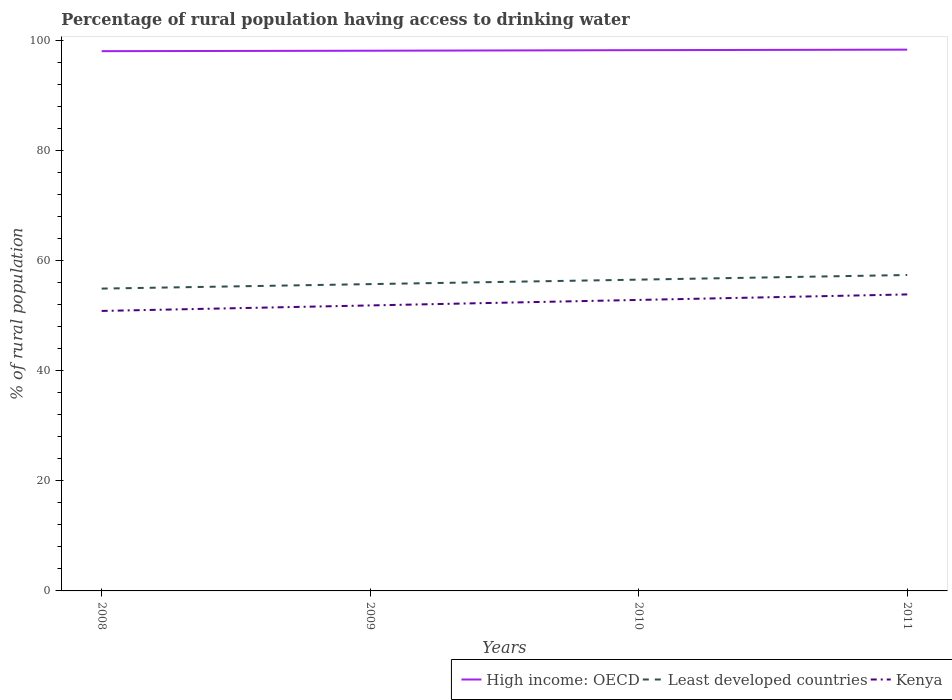How many different coloured lines are there?
Keep it short and to the point. 3. Does the line corresponding to Least developed countries intersect with the line corresponding to Kenya?
Provide a short and direct response. No. Is the number of lines equal to the number of legend labels?
Offer a very short reply. Yes. Across all years, what is the maximum percentage of rural population having access to drinking water in Least developed countries?
Your answer should be compact. 54.96. What is the total percentage of rural population having access to drinking water in Least developed countries in the graph?
Give a very brief answer. -1.66. What is the difference between the highest and the second highest percentage of rural population having access to drinking water in High income: OECD?
Your answer should be compact. 0.28. What is the difference between the highest and the lowest percentage of rural population having access to drinking water in High income: OECD?
Make the answer very short. 2. How many lines are there?
Offer a very short reply. 3. What is the difference between two consecutive major ticks on the Y-axis?
Offer a very short reply. 20. Are the values on the major ticks of Y-axis written in scientific E-notation?
Provide a succinct answer. No. Does the graph contain grids?
Offer a very short reply. No. Where does the legend appear in the graph?
Provide a short and direct response. Bottom right. What is the title of the graph?
Ensure brevity in your answer.  Percentage of rural population having access to drinking water. Does "Iraq" appear as one of the legend labels in the graph?
Give a very brief answer. No. What is the label or title of the Y-axis?
Provide a succinct answer. % of rural population. What is the % of rural population of High income: OECD in 2008?
Your answer should be very brief. 98.12. What is the % of rural population of Least developed countries in 2008?
Offer a terse response. 54.96. What is the % of rural population of Kenya in 2008?
Offer a very short reply. 50.9. What is the % of rural population in High income: OECD in 2009?
Your answer should be very brief. 98.2. What is the % of rural population of Least developed countries in 2009?
Provide a short and direct response. 55.77. What is the % of rural population of Kenya in 2009?
Provide a short and direct response. 51.9. What is the % of rural population of High income: OECD in 2010?
Provide a succinct answer. 98.31. What is the % of rural population in Least developed countries in 2010?
Provide a succinct answer. 56.59. What is the % of rural population in Kenya in 2010?
Your response must be concise. 52.9. What is the % of rural population in High income: OECD in 2011?
Give a very brief answer. 98.4. What is the % of rural population in Least developed countries in 2011?
Keep it short and to the point. 57.43. What is the % of rural population of Kenya in 2011?
Provide a short and direct response. 53.9. Across all years, what is the maximum % of rural population of High income: OECD?
Your response must be concise. 98.4. Across all years, what is the maximum % of rural population in Least developed countries?
Give a very brief answer. 57.43. Across all years, what is the maximum % of rural population in Kenya?
Ensure brevity in your answer.  53.9. Across all years, what is the minimum % of rural population in High income: OECD?
Your answer should be very brief. 98.12. Across all years, what is the minimum % of rural population in Least developed countries?
Your answer should be compact. 54.96. Across all years, what is the minimum % of rural population in Kenya?
Your response must be concise. 50.9. What is the total % of rural population in High income: OECD in the graph?
Give a very brief answer. 393.03. What is the total % of rural population in Least developed countries in the graph?
Make the answer very short. 224.75. What is the total % of rural population in Kenya in the graph?
Give a very brief answer. 209.6. What is the difference between the % of rural population in High income: OECD in 2008 and that in 2009?
Offer a terse response. -0.08. What is the difference between the % of rural population of Least developed countries in 2008 and that in 2009?
Offer a very short reply. -0.81. What is the difference between the % of rural population in High income: OECD in 2008 and that in 2010?
Your answer should be compact. -0.18. What is the difference between the % of rural population in Least developed countries in 2008 and that in 2010?
Your answer should be compact. -1.63. What is the difference between the % of rural population of Kenya in 2008 and that in 2010?
Your answer should be compact. -2. What is the difference between the % of rural population of High income: OECD in 2008 and that in 2011?
Offer a terse response. -0.28. What is the difference between the % of rural population in Least developed countries in 2008 and that in 2011?
Keep it short and to the point. -2.47. What is the difference between the % of rural population of Kenya in 2008 and that in 2011?
Ensure brevity in your answer.  -3. What is the difference between the % of rural population of High income: OECD in 2009 and that in 2010?
Keep it short and to the point. -0.1. What is the difference between the % of rural population in Least developed countries in 2009 and that in 2010?
Give a very brief answer. -0.81. What is the difference between the % of rural population in Kenya in 2009 and that in 2010?
Make the answer very short. -1. What is the difference between the % of rural population of High income: OECD in 2009 and that in 2011?
Give a very brief answer. -0.2. What is the difference between the % of rural population of Least developed countries in 2009 and that in 2011?
Provide a short and direct response. -1.66. What is the difference between the % of rural population in Kenya in 2009 and that in 2011?
Keep it short and to the point. -2. What is the difference between the % of rural population in High income: OECD in 2010 and that in 2011?
Your response must be concise. -0.09. What is the difference between the % of rural population in Least developed countries in 2010 and that in 2011?
Give a very brief answer. -0.84. What is the difference between the % of rural population in High income: OECD in 2008 and the % of rural population in Least developed countries in 2009?
Give a very brief answer. 42.35. What is the difference between the % of rural population of High income: OECD in 2008 and the % of rural population of Kenya in 2009?
Give a very brief answer. 46.22. What is the difference between the % of rural population of Least developed countries in 2008 and the % of rural population of Kenya in 2009?
Your answer should be compact. 3.06. What is the difference between the % of rural population in High income: OECD in 2008 and the % of rural population in Least developed countries in 2010?
Keep it short and to the point. 41.53. What is the difference between the % of rural population of High income: OECD in 2008 and the % of rural population of Kenya in 2010?
Make the answer very short. 45.22. What is the difference between the % of rural population of Least developed countries in 2008 and the % of rural population of Kenya in 2010?
Your answer should be compact. 2.06. What is the difference between the % of rural population in High income: OECD in 2008 and the % of rural population in Least developed countries in 2011?
Your answer should be very brief. 40.69. What is the difference between the % of rural population in High income: OECD in 2008 and the % of rural population in Kenya in 2011?
Your answer should be very brief. 44.22. What is the difference between the % of rural population of Least developed countries in 2008 and the % of rural population of Kenya in 2011?
Give a very brief answer. 1.06. What is the difference between the % of rural population in High income: OECD in 2009 and the % of rural population in Least developed countries in 2010?
Your answer should be compact. 41.62. What is the difference between the % of rural population of High income: OECD in 2009 and the % of rural population of Kenya in 2010?
Your response must be concise. 45.3. What is the difference between the % of rural population in Least developed countries in 2009 and the % of rural population in Kenya in 2010?
Ensure brevity in your answer.  2.87. What is the difference between the % of rural population in High income: OECD in 2009 and the % of rural population in Least developed countries in 2011?
Keep it short and to the point. 40.77. What is the difference between the % of rural population in High income: OECD in 2009 and the % of rural population in Kenya in 2011?
Keep it short and to the point. 44.3. What is the difference between the % of rural population of Least developed countries in 2009 and the % of rural population of Kenya in 2011?
Ensure brevity in your answer.  1.87. What is the difference between the % of rural population in High income: OECD in 2010 and the % of rural population in Least developed countries in 2011?
Offer a very short reply. 40.88. What is the difference between the % of rural population of High income: OECD in 2010 and the % of rural population of Kenya in 2011?
Keep it short and to the point. 44.41. What is the difference between the % of rural population in Least developed countries in 2010 and the % of rural population in Kenya in 2011?
Your answer should be very brief. 2.69. What is the average % of rural population in High income: OECD per year?
Keep it short and to the point. 98.26. What is the average % of rural population of Least developed countries per year?
Offer a terse response. 56.19. What is the average % of rural population of Kenya per year?
Give a very brief answer. 52.4. In the year 2008, what is the difference between the % of rural population of High income: OECD and % of rural population of Least developed countries?
Give a very brief answer. 43.16. In the year 2008, what is the difference between the % of rural population of High income: OECD and % of rural population of Kenya?
Give a very brief answer. 47.22. In the year 2008, what is the difference between the % of rural population of Least developed countries and % of rural population of Kenya?
Your response must be concise. 4.06. In the year 2009, what is the difference between the % of rural population of High income: OECD and % of rural population of Least developed countries?
Your response must be concise. 42.43. In the year 2009, what is the difference between the % of rural population in High income: OECD and % of rural population in Kenya?
Your answer should be very brief. 46.3. In the year 2009, what is the difference between the % of rural population in Least developed countries and % of rural population in Kenya?
Give a very brief answer. 3.87. In the year 2010, what is the difference between the % of rural population in High income: OECD and % of rural population in Least developed countries?
Give a very brief answer. 41.72. In the year 2010, what is the difference between the % of rural population in High income: OECD and % of rural population in Kenya?
Offer a very short reply. 45.41. In the year 2010, what is the difference between the % of rural population of Least developed countries and % of rural population of Kenya?
Ensure brevity in your answer.  3.69. In the year 2011, what is the difference between the % of rural population of High income: OECD and % of rural population of Least developed countries?
Provide a succinct answer. 40.97. In the year 2011, what is the difference between the % of rural population of High income: OECD and % of rural population of Kenya?
Make the answer very short. 44.5. In the year 2011, what is the difference between the % of rural population of Least developed countries and % of rural population of Kenya?
Keep it short and to the point. 3.53. What is the ratio of the % of rural population of Least developed countries in 2008 to that in 2009?
Your answer should be very brief. 0.99. What is the ratio of the % of rural population of Kenya in 2008 to that in 2009?
Your response must be concise. 0.98. What is the ratio of the % of rural population in High income: OECD in 2008 to that in 2010?
Your response must be concise. 1. What is the ratio of the % of rural population of Least developed countries in 2008 to that in 2010?
Offer a very short reply. 0.97. What is the ratio of the % of rural population of Kenya in 2008 to that in 2010?
Your answer should be very brief. 0.96. What is the ratio of the % of rural population of Least developed countries in 2008 to that in 2011?
Offer a very short reply. 0.96. What is the ratio of the % of rural population in Kenya in 2008 to that in 2011?
Make the answer very short. 0.94. What is the ratio of the % of rural population in Least developed countries in 2009 to that in 2010?
Give a very brief answer. 0.99. What is the ratio of the % of rural population of Kenya in 2009 to that in 2010?
Provide a short and direct response. 0.98. What is the ratio of the % of rural population of Least developed countries in 2009 to that in 2011?
Ensure brevity in your answer.  0.97. What is the ratio of the % of rural population in Kenya in 2009 to that in 2011?
Provide a short and direct response. 0.96. What is the ratio of the % of rural population in Least developed countries in 2010 to that in 2011?
Provide a short and direct response. 0.99. What is the ratio of the % of rural population of Kenya in 2010 to that in 2011?
Your answer should be very brief. 0.98. What is the difference between the highest and the second highest % of rural population of High income: OECD?
Offer a very short reply. 0.09. What is the difference between the highest and the second highest % of rural population in Least developed countries?
Provide a short and direct response. 0.84. What is the difference between the highest and the second highest % of rural population in Kenya?
Your answer should be compact. 1. What is the difference between the highest and the lowest % of rural population of High income: OECD?
Ensure brevity in your answer.  0.28. What is the difference between the highest and the lowest % of rural population in Least developed countries?
Your response must be concise. 2.47. What is the difference between the highest and the lowest % of rural population in Kenya?
Your answer should be very brief. 3. 